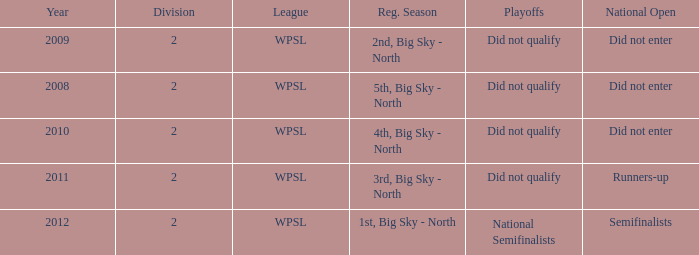Can you parse all the data within this table? {'header': ['Year', 'Division', 'League', 'Reg. Season', 'Playoffs', 'National Open'], 'rows': [['2009', '2', 'WPSL', '2nd, Big Sky - North', 'Did not qualify', 'Did not enter'], ['2008', '2', 'WPSL', '5th, Big Sky - North', 'Did not qualify', 'Did not enter'], ['2010', '2', 'WPSL', '4th, Big Sky - North', 'Did not qualify', 'Did not enter'], ['2011', '2', 'WPSL', '3rd, Big Sky - North', 'Did not qualify', 'Runners-up'], ['2012', '2', 'WPSL', '1st, Big Sky - North', 'National Semifinalists', 'Semifinalists']]} What is the highest number of divisions mentioned? 2.0. 